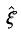<formula> <loc_0><loc_0><loc_500><loc_500>\hat { \xi }</formula> 